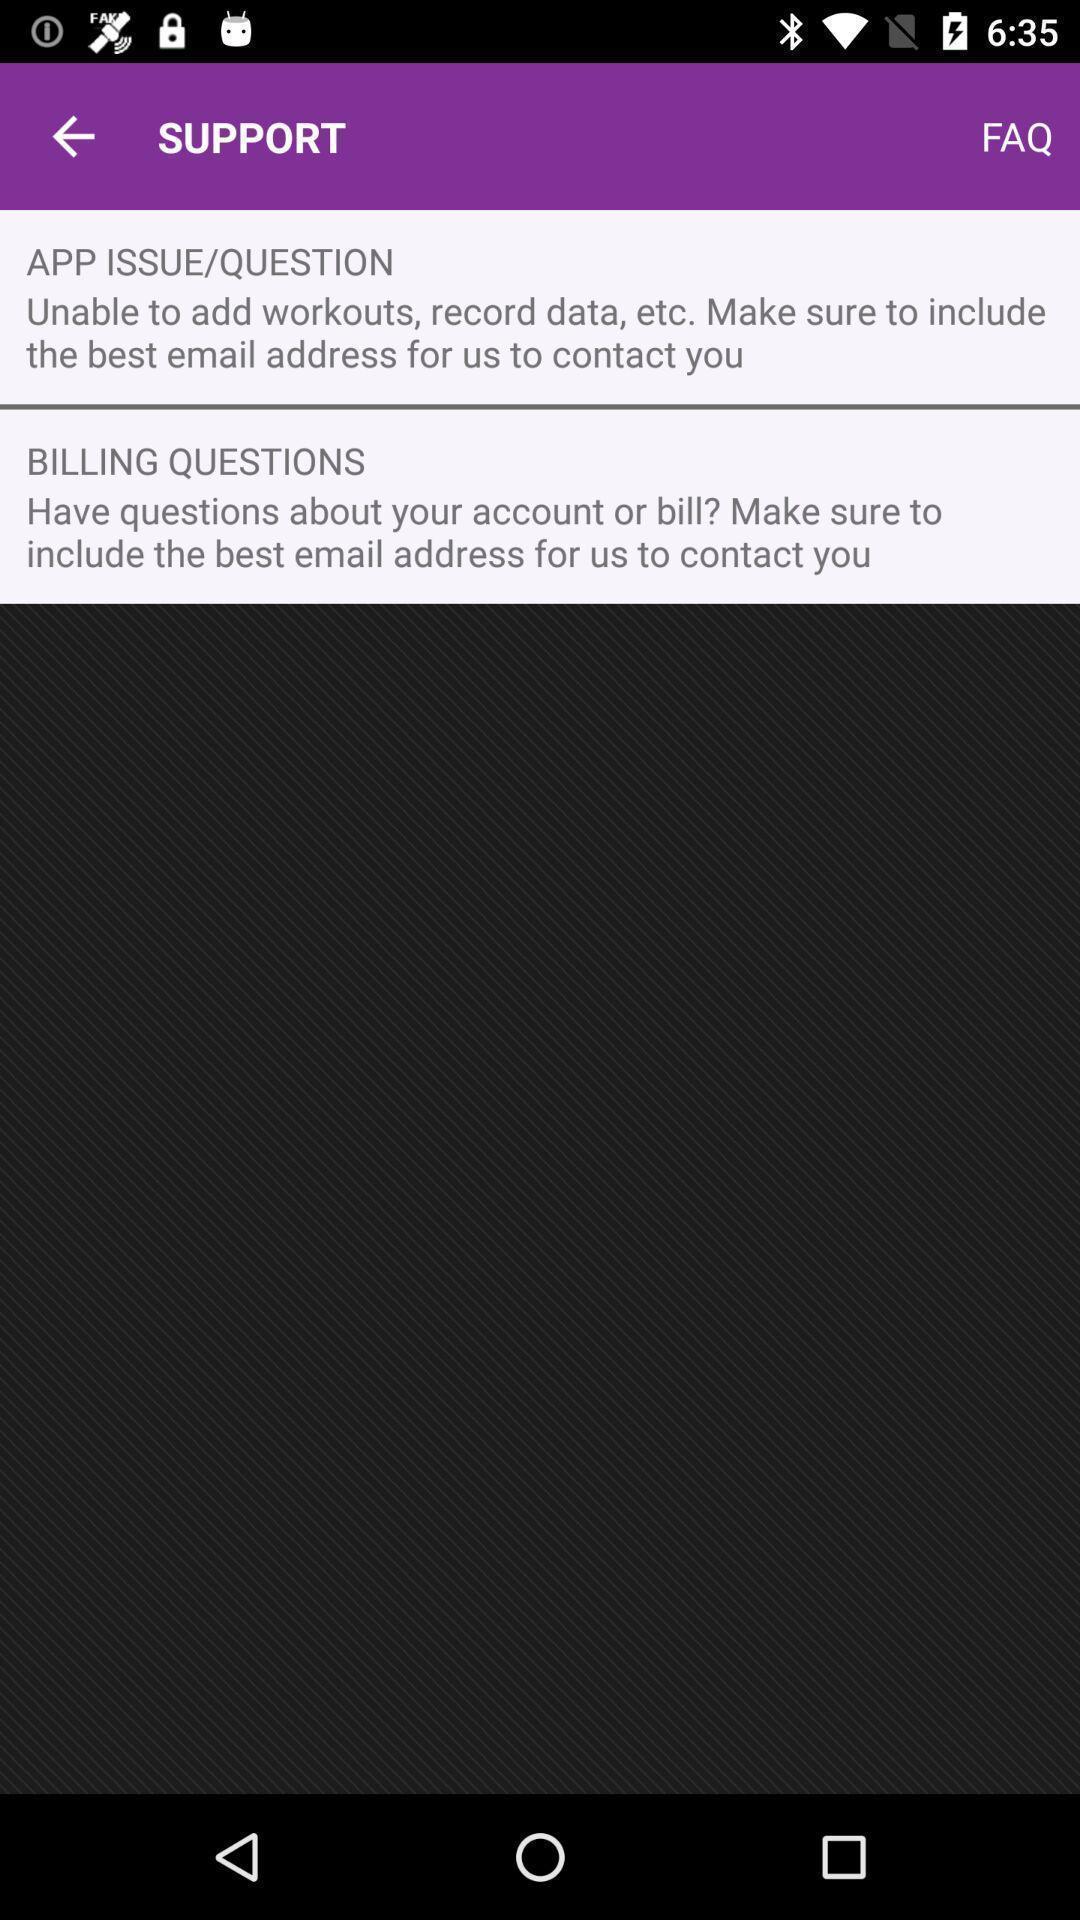Provide a textual representation of this image. Support page. 